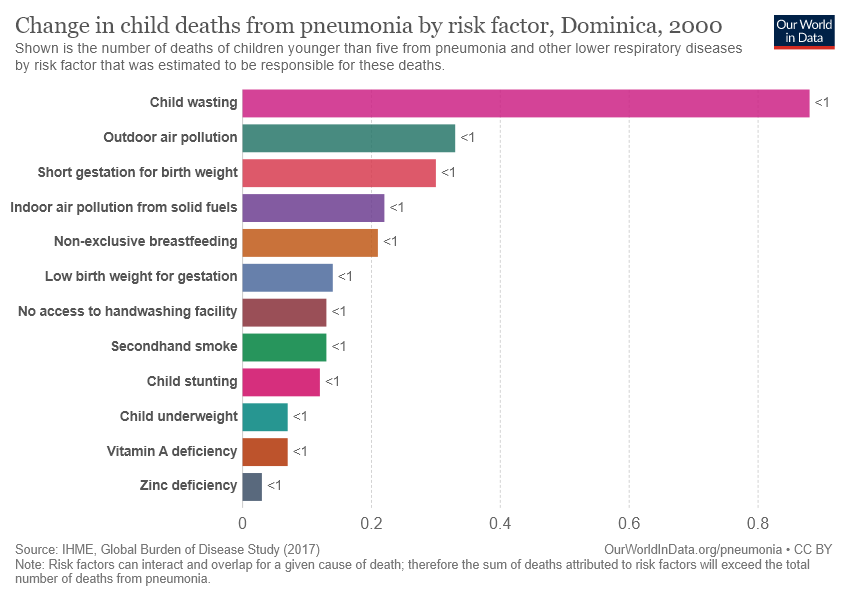Draw attention to some important aspects in this diagram. The total number of bars is not less than 10. No. The largest bar in the chart represents child wasting, which is a serious issue of child malnutrition. 